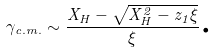Convert formula to latex. <formula><loc_0><loc_0><loc_500><loc_500>\gamma _ { c . m . } \sim \frac { X _ { H } - \sqrt { X _ { H } ^ { 2 } - z _ { 1 } \xi } } { \xi } \text {.}</formula> 